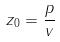Convert formula to latex. <formula><loc_0><loc_0><loc_500><loc_500>z _ { 0 } = \frac { p } { v }</formula> 